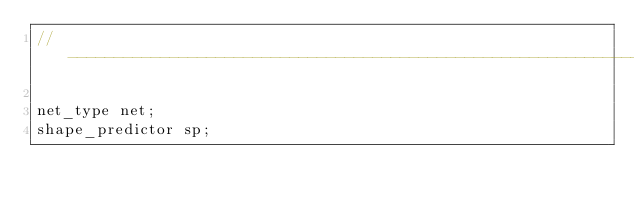<code> <loc_0><loc_0><loc_500><loc_500><_ObjectiveC_>// ----------------------------------------------------------------------------------------

net_type net;
shape_predictor sp;

</code> 